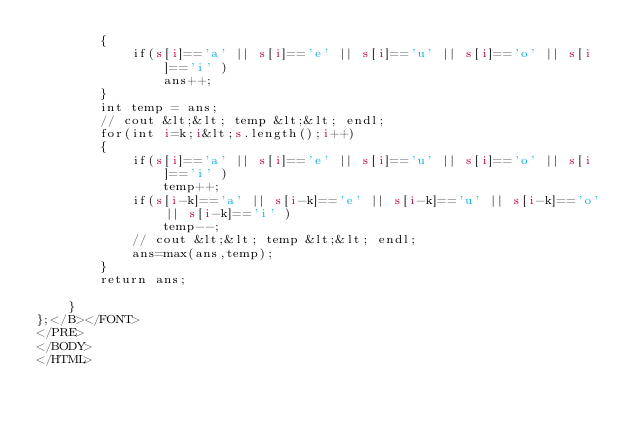Convert code to text. <code><loc_0><loc_0><loc_500><loc_500><_HTML_>        {
            if(s[i]=='a' || s[i]=='e' || s[i]=='u' || s[i]=='o' || s[i]=='i' )
                ans++;
        }
        int temp = ans;
        // cout &lt;&lt; temp &lt;&lt; endl;
        for(int i=k;i&lt;s.length();i++)
        {
            if(s[i]=='a' || s[i]=='e' || s[i]=='u' || s[i]=='o' || s[i]=='i' )
                temp++;
            if(s[i-k]=='a' || s[i-k]=='e' || s[i-k]=='u' || s[i-k]=='o' || s[i-k]=='i' )
                temp--;
            // cout &lt;&lt; temp &lt;&lt; endl;
            ans=max(ans,temp);
        }
        return ans;
        
    }
};</B></FONT>
</PRE>
</BODY>
</HTML>
</code> 